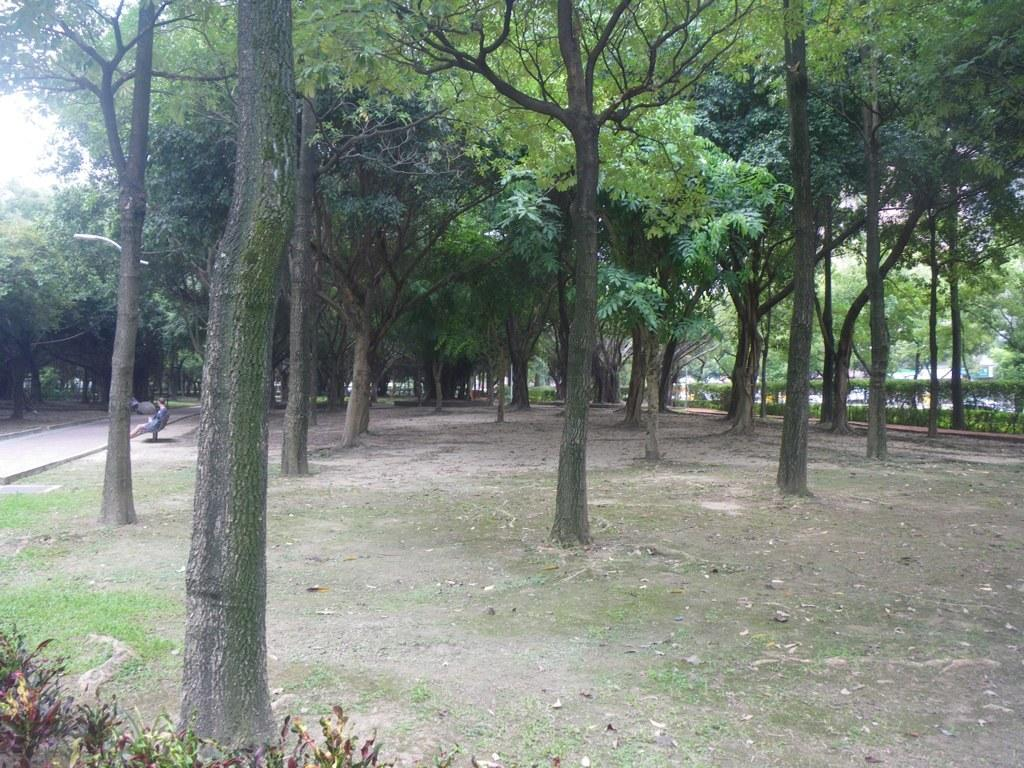What type of location is suggested by the image? The image was likely taken in a park. What can be seen in the trees in the image? There are trees with branches and leaves in the image. What type of vegetation is present besides the trees? Small bushes are visible in the image. What is the person in the image doing? There is a person sitting on a bench in the image. What type of pathway is visible in the image? There is a pathway in the image. What type of quilt is being used to cover the person sitting on the bench in the image? There is no quilt present in the image; the person is sitting on a bench without any covering. How does the person sitting on the bench in the image express regret? There is no indication of regret in the image, as the person is simply sitting on a bench. 